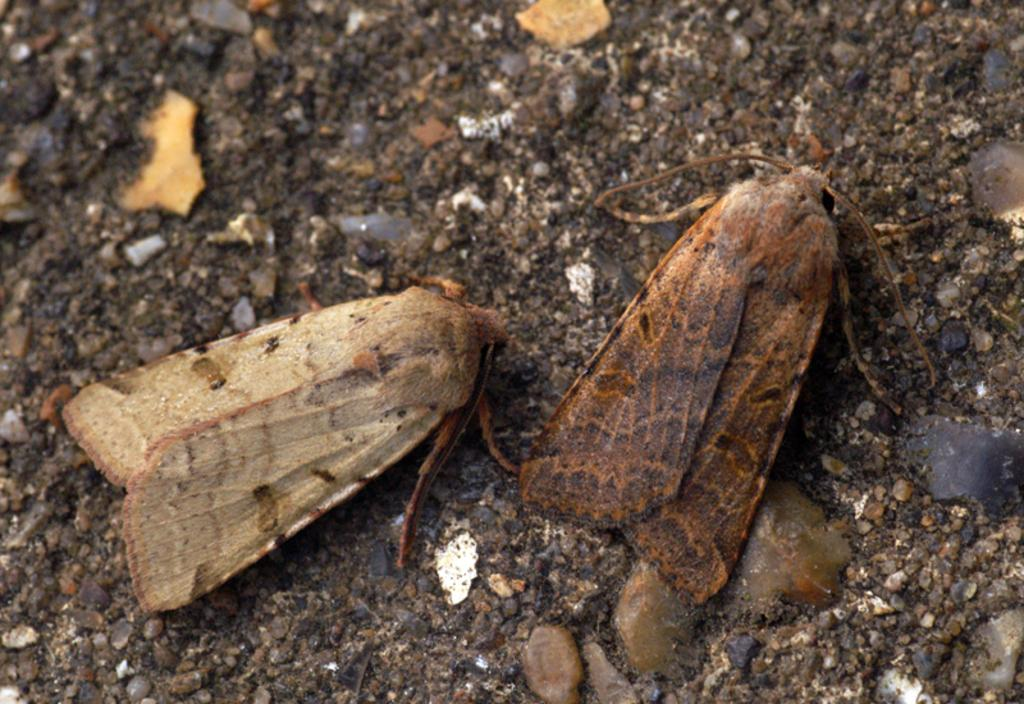What type of animals are on the ground in the image? There are butterflies on the ground in the image. What color is the stone cushion in the image? There is no stone cushion present in the image; it only features butterflies on the ground. 